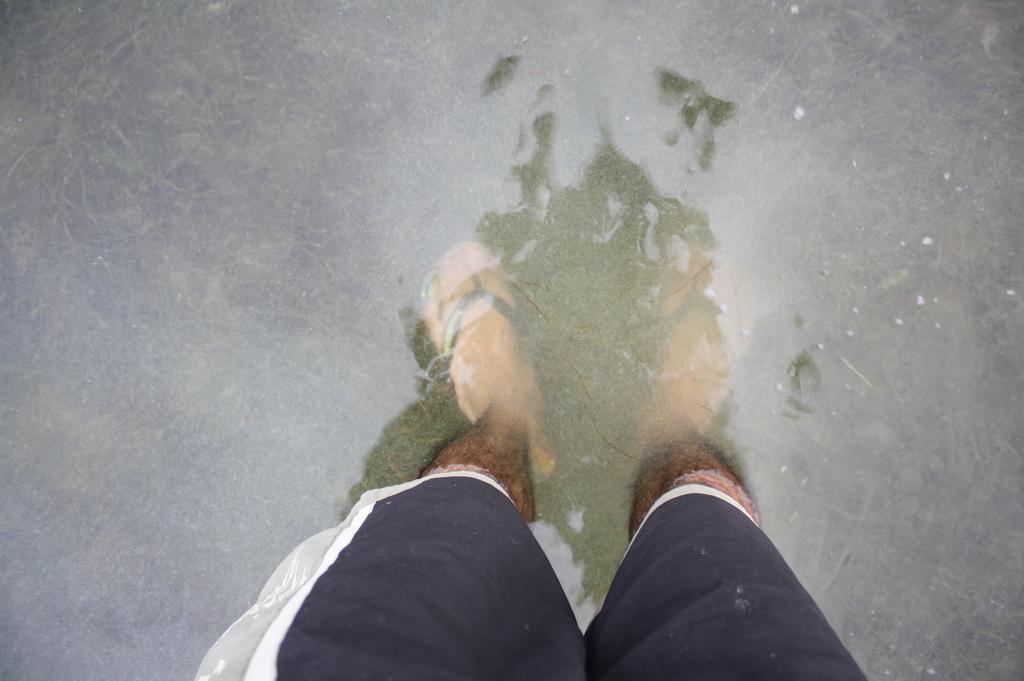In one or two sentences, can you explain what this image depicts? In this image we can see the legs of a person inside the water. 